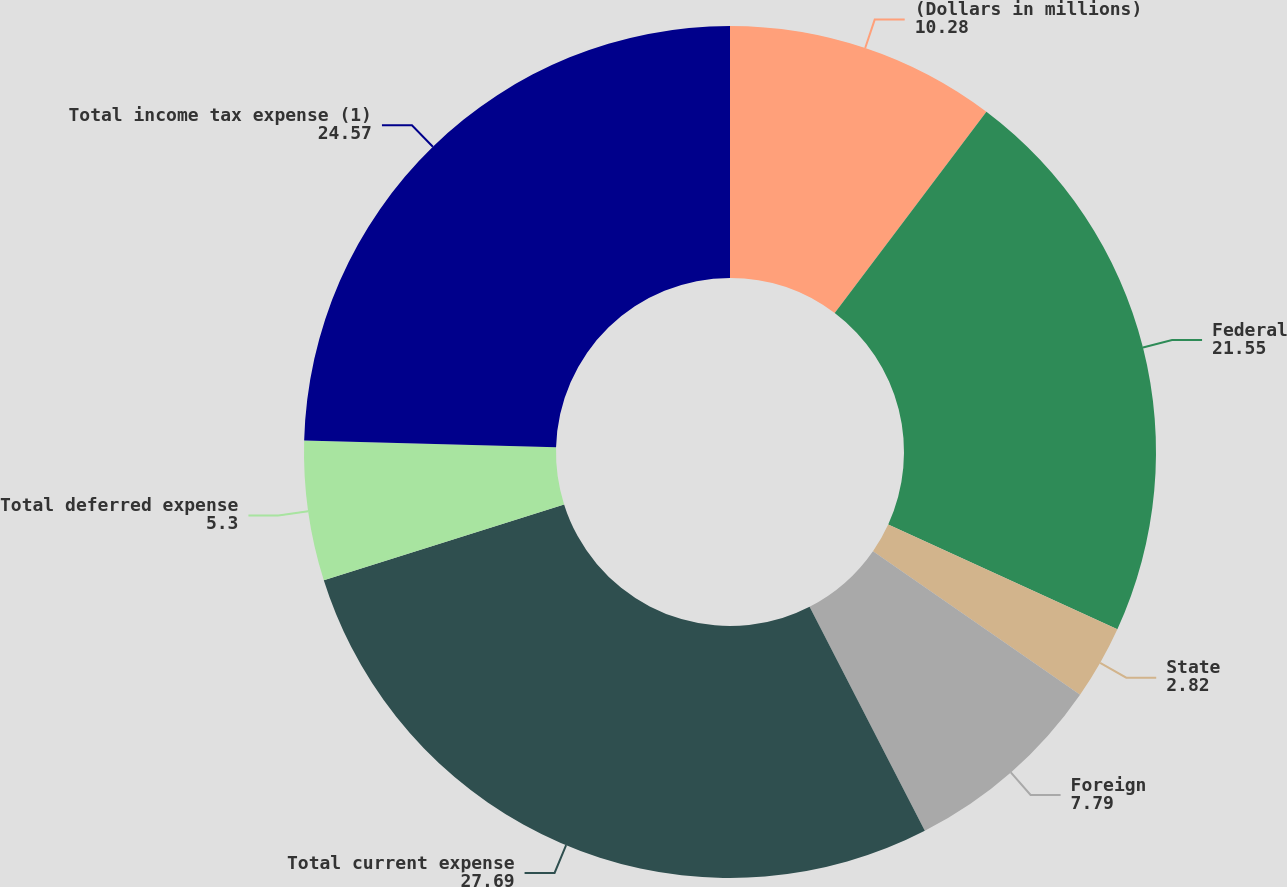Convert chart to OTSL. <chart><loc_0><loc_0><loc_500><loc_500><pie_chart><fcel>(Dollars in millions)<fcel>Federal<fcel>State<fcel>Foreign<fcel>Total current expense<fcel>Total deferred expense<fcel>Total income tax expense (1)<nl><fcel>10.28%<fcel>21.55%<fcel>2.82%<fcel>7.79%<fcel>27.69%<fcel>5.3%<fcel>24.57%<nl></chart> 